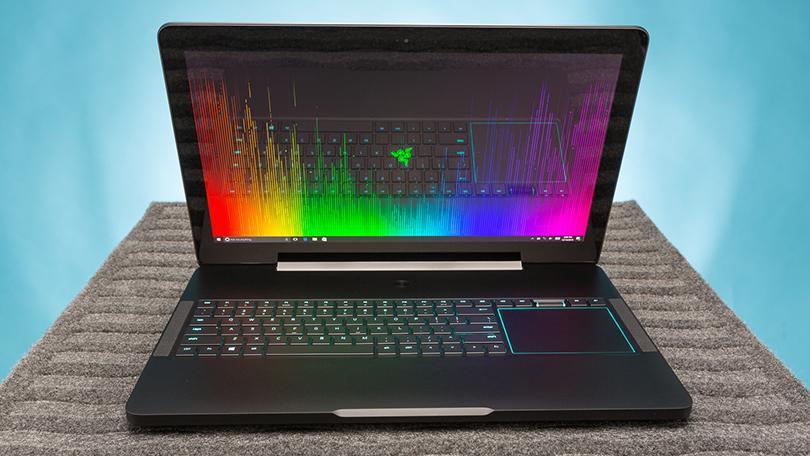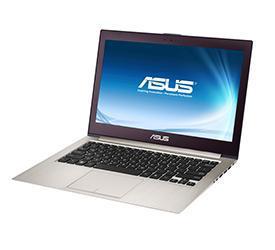The first image is the image on the left, the second image is the image on the right. For the images displayed, is the sentence "The laptop in the image on the left is facing right." factually correct? Answer yes or no. No. 